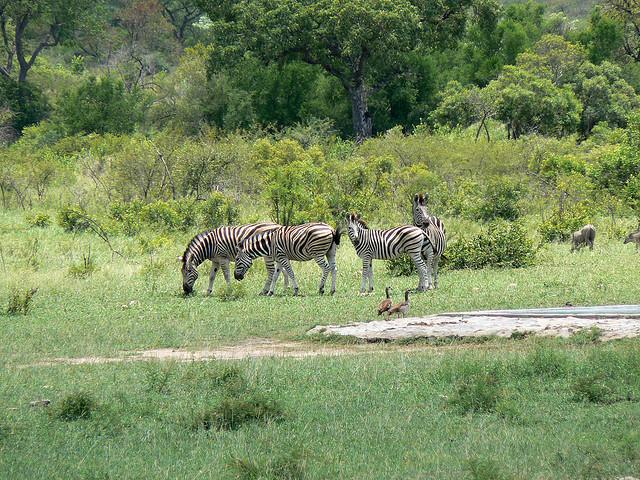Is this a close up picture of the zebras?
Write a very short answer. No. Are these animals protected?
Give a very brief answer. No. How many zebras do you see?
Give a very brief answer. 4. What type of animal is walking in front of the zebras?
Short answer required. Birds. 